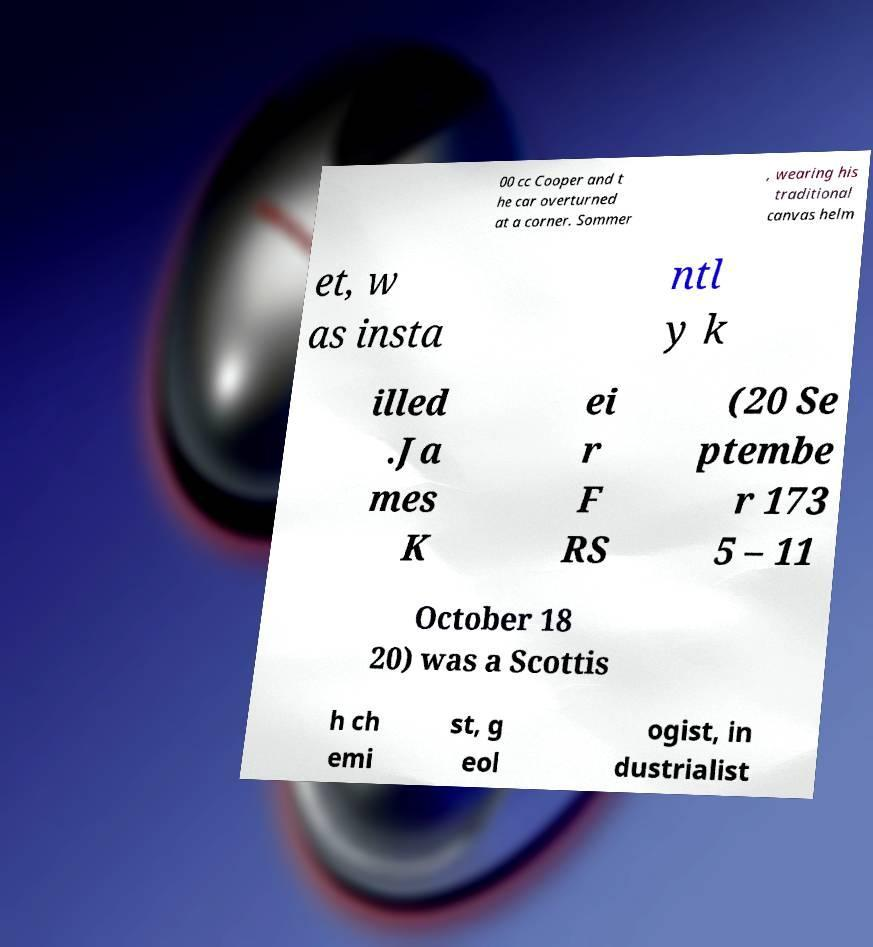Please read and relay the text visible in this image. What does it say? 00 cc Cooper and t he car overturned at a corner. Sommer , wearing his traditional canvas helm et, w as insta ntl y k illed .Ja mes K ei r F RS (20 Se ptembe r 173 5 – 11 October 18 20) was a Scottis h ch emi st, g eol ogist, in dustrialist 